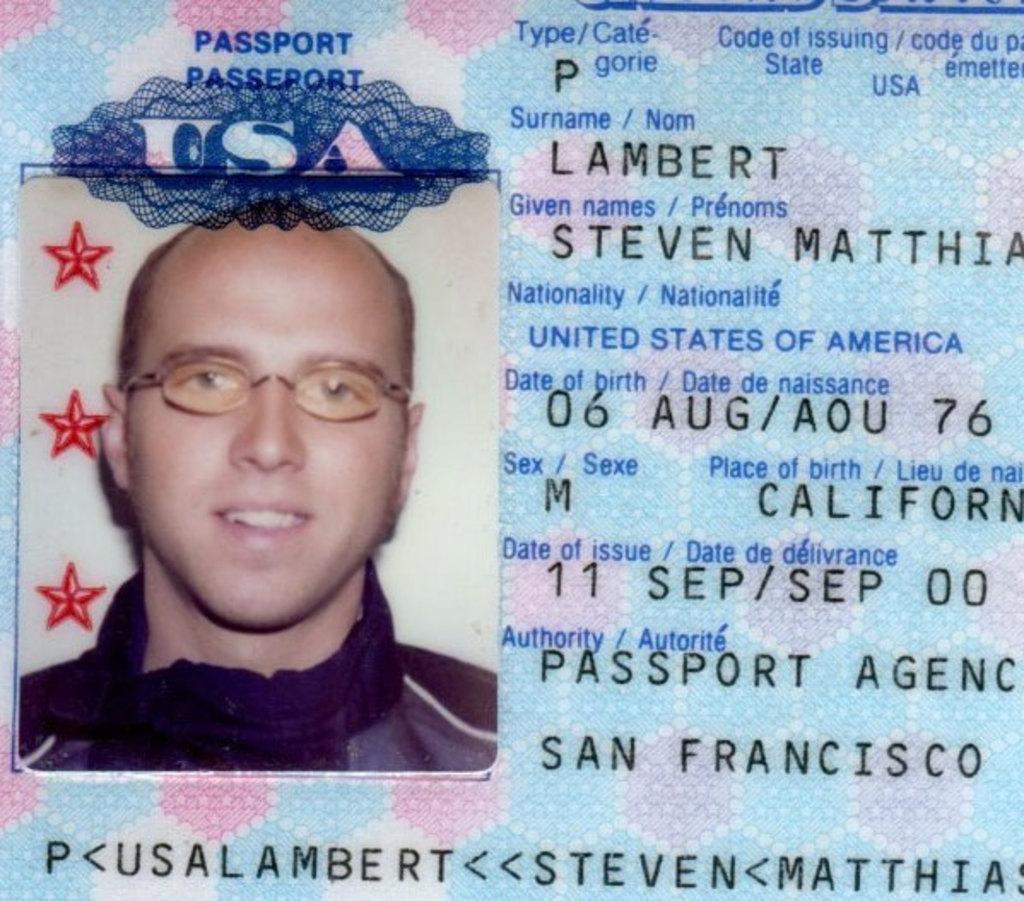In one or two sentences, can you explain what this image depicts? In this picture there is some text and numbers written and there is the image of the person who is smiling. 